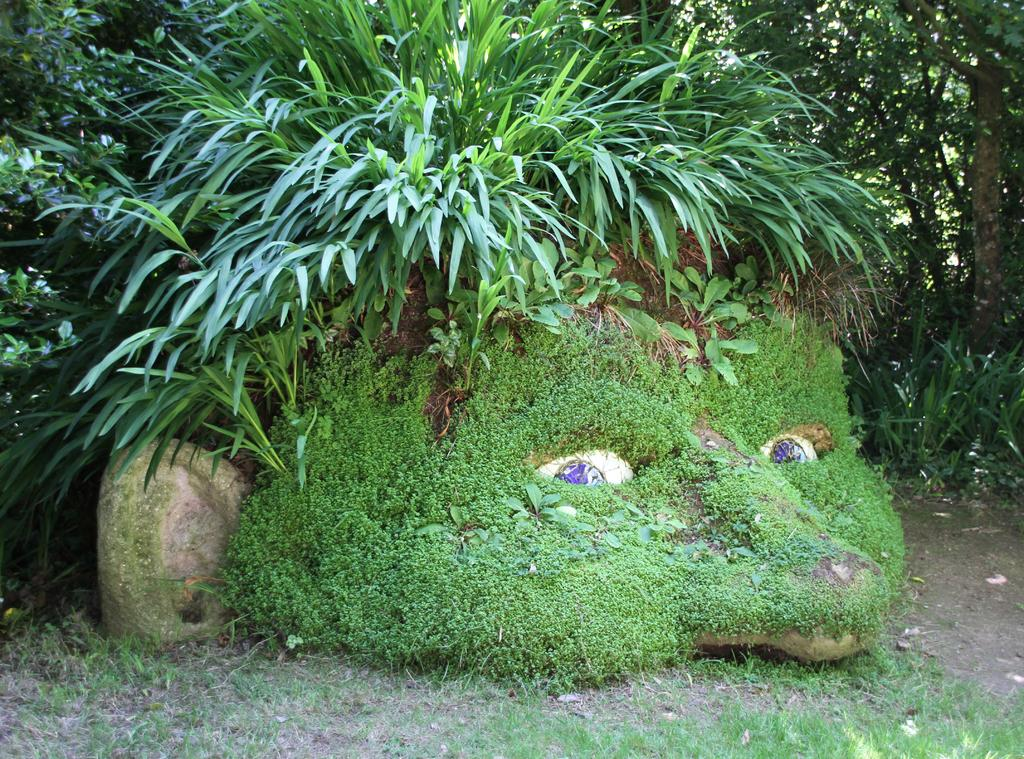What type of vegetation can be seen in the image? There are trees and plants in the image. How are some of the plants positioned in the image? Some plants are on stones in the image. What type of ground cover is visible in the image? There is grass on the ground in the image. What type of soup is being served in the image? There is no soup present in the image; it features trees, plants, and grass. Is there a sister in the image? There is no mention of a sister or any people in the image. 